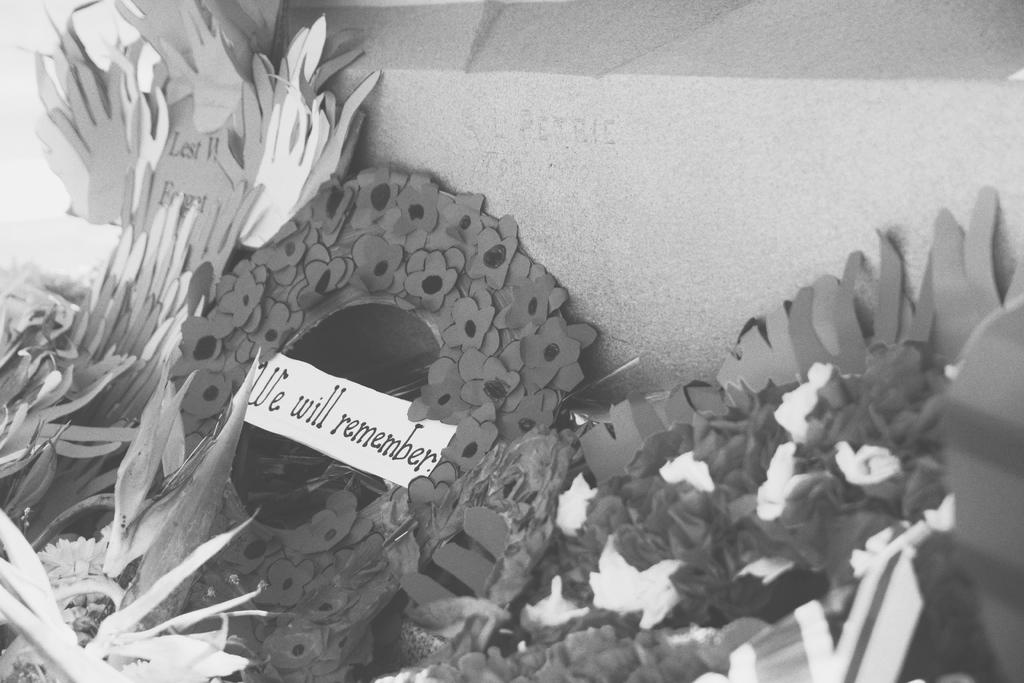What type of flowers are visible in the foreground of the image? There are paper flowers in the foreground of the image. What else can be seen in the foreground of the image? There is a paper with text in the foreground of the image. Can you describe the object at the top of the image? There is a stone at the top of the image. What type of card is being held by the person in jail in the image? There is no person in jail or any card present in the image. What type of rose can be seen in the image? There are no roses present in the image; only paper flowers are visible. 